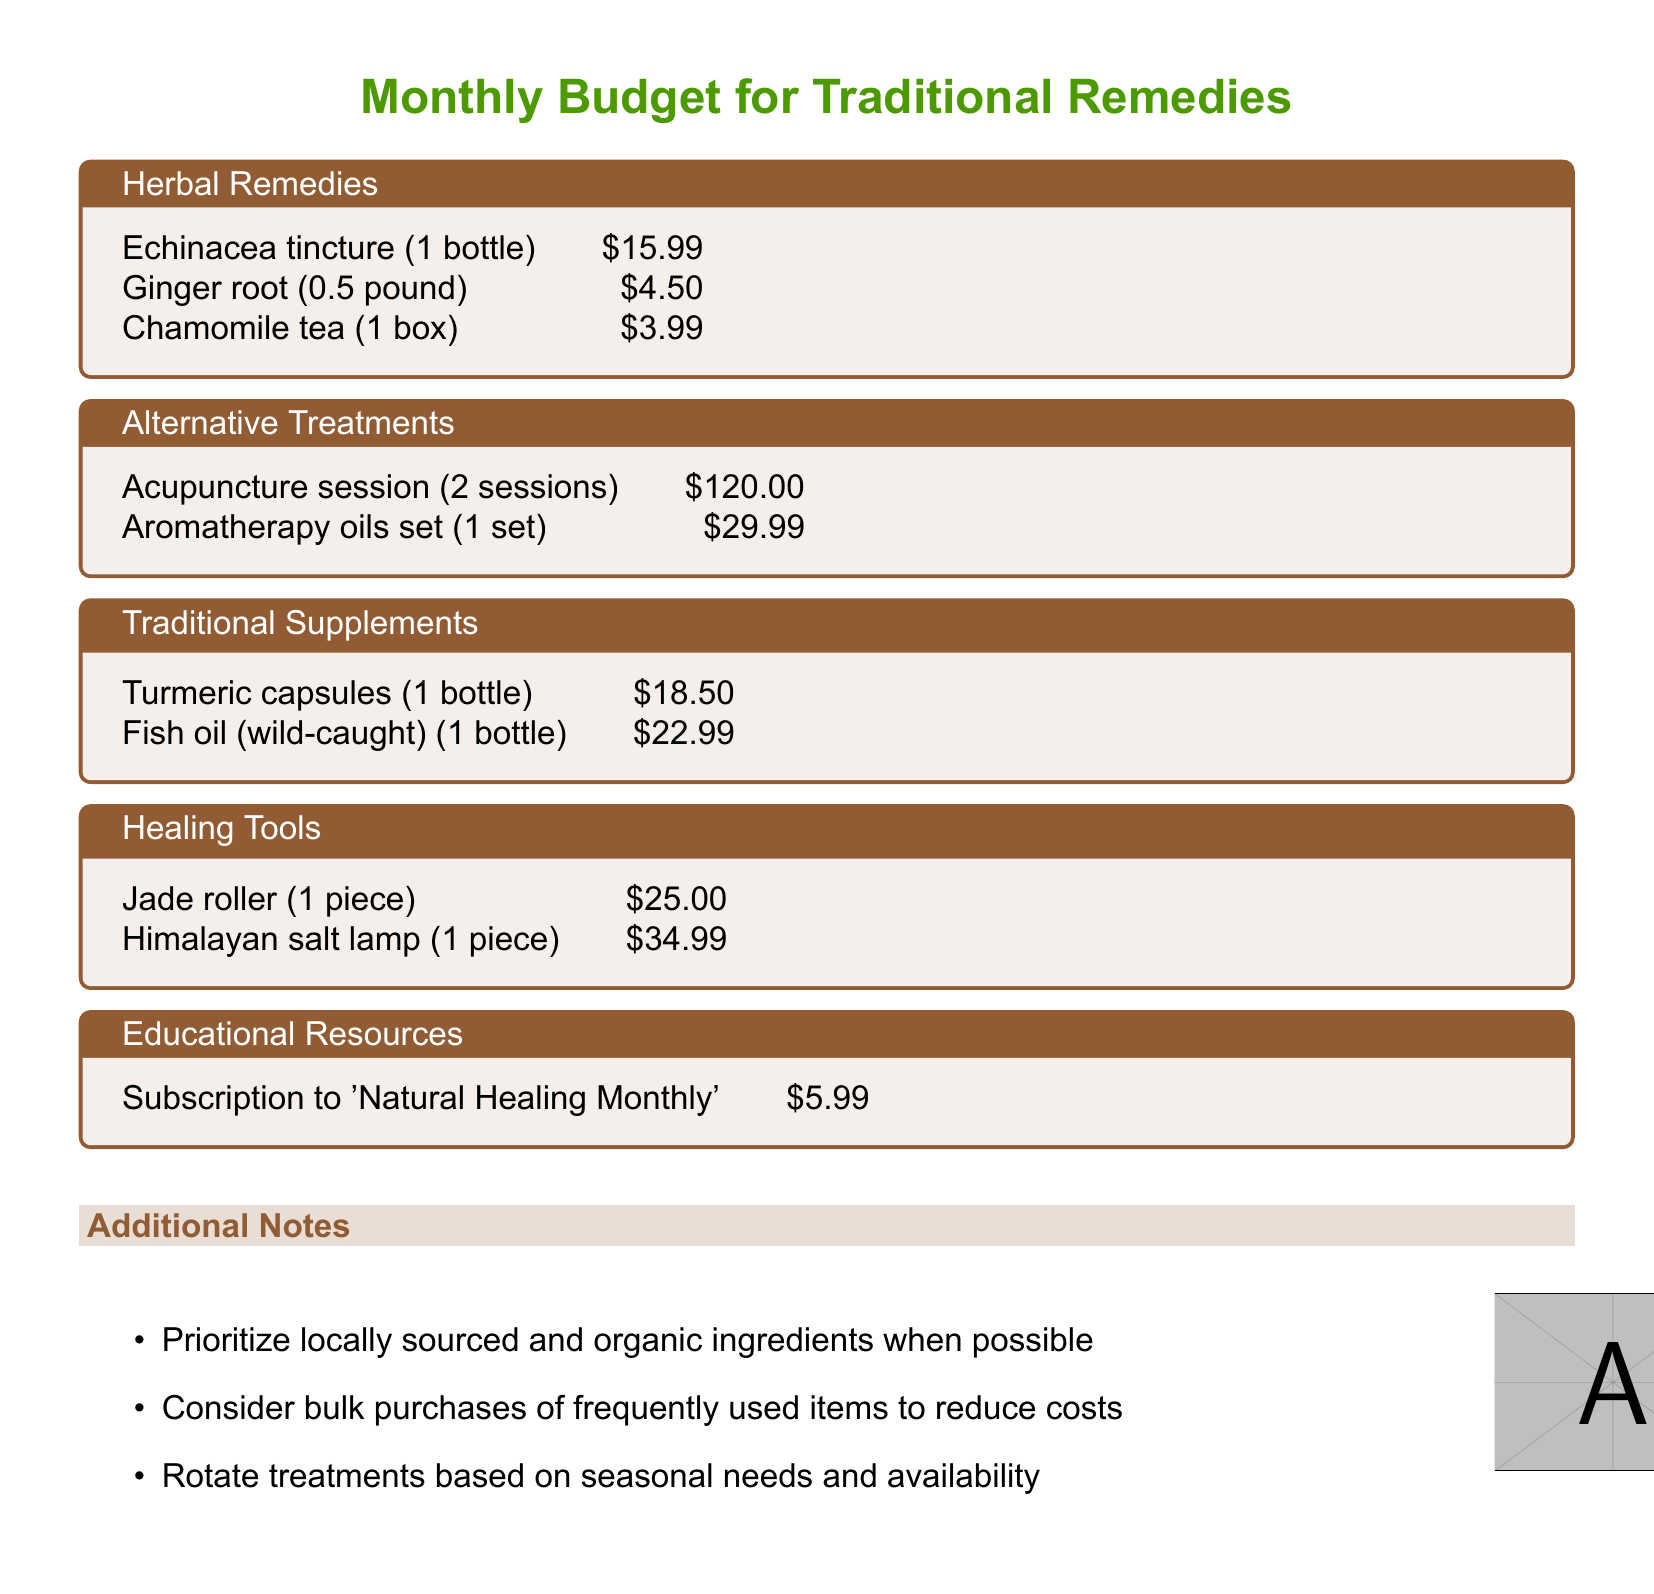What is the cost of Echinacea tincture? The cost of Echinacea tincture is mentioned in the herbal remedies section, specifically listed as $15.99.
Answer: $15.99 How many sessions of acupuncture are included? The document states that there are 2 sessions of acupuncture listed in the alternative treatments section.
Answer: 2 sessions What is the price of a turmeric capsules bottle? The price of turmeric capsules is provided under traditional supplements, which is $18.50.
Answer: $18.50 Which healing tool is the most expensive? By comparing the prices in the healing tools section, the Himalayan salt lamp is noted as the most expensive item at $34.99.
Answer: Himalayan salt lamp What is the total cost for all herbal remedies? To find the total, we add the prices of Echinacea tincture, ginger root, and chamomile tea, which amounts to $15.99 + $4.50 + $3.99 = $24.48.
Answer: $24.48 What is the price of the educational resource subscription? The document indicates that the subscription to 'Natural Healing Monthly' costs $5.99.
Answer: $5.99 How much would it cost to buy 1 bottle of fish oil? The cost for one bottle of fish oil is specified in the traditional supplements section as $22.99.
Answer: $22.99 What is suggested for cost reduction in purchasing items? The document advises considering bulk purchases of frequently used items to help manage costs.
Answer: Bulk purchases What type of resources are prioritized and suggested for purchasing? The additional notes section indicates to prioritize locally sourced and organic ingredients when purchasing.
Answer: Locally sourced and organic ingredients 